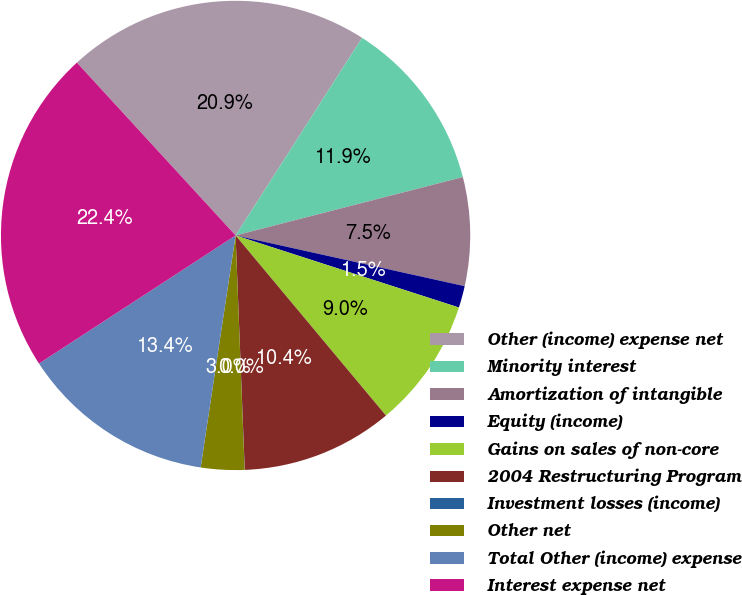<chart> <loc_0><loc_0><loc_500><loc_500><pie_chart><fcel>Other (income) expense net<fcel>Minority interest<fcel>Amortization of intangible<fcel>Equity (income)<fcel>Gains on sales of non-core<fcel>2004 Restructuring Program<fcel>Investment losses (income)<fcel>Other net<fcel>Total Other (income) expense<fcel>Interest expense net<nl><fcel>20.88%<fcel>11.94%<fcel>7.47%<fcel>1.5%<fcel>8.96%<fcel>10.45%<fcel>0.01%<fcel>2.99%<fcel>13.43%<fcel>22.37%<nl></chart> 